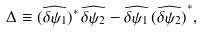<formula> <loc_0><loc_0><loc_500><loc_500>\Delta \equiv ( \widehat { \delta \psi _ { 1 } } ) ^ { \ast } \, \widehat { \delta \psi _ { 2 } } - \widehat { \delta \psi _ { 1 } } \, { ( \widehat { \delta \psi _ { 2 } } ) } ^ { \ast } ,</formula> 